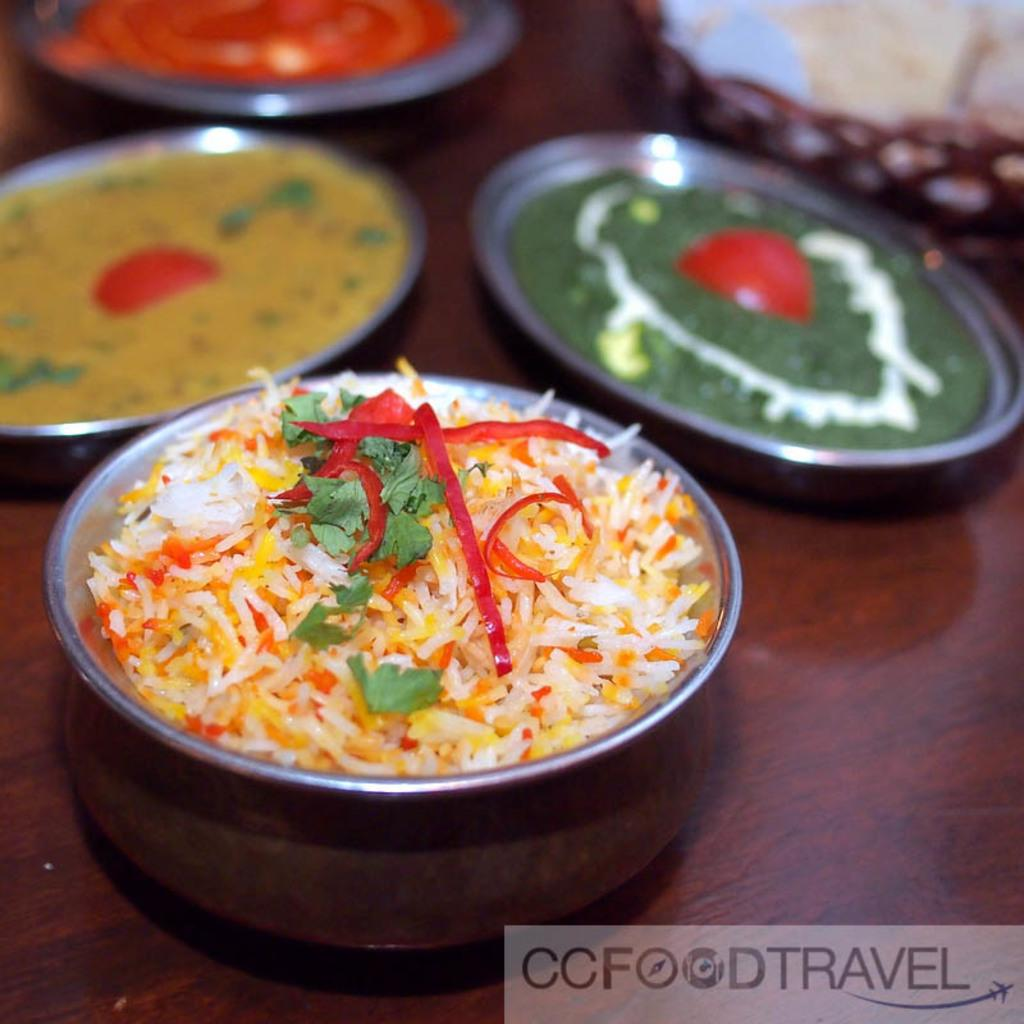What is present in the image that can hold food? There is a bowl and plates in the image that can hold food. What other object can be seen in the image? There is a basket in the image. What type of surface is visible in the image? The wooden surface is visible in the image. Can you describe the food in the image? The image contains food, but the specific type of food is not mentioned. What type of lace can be seen on the plates in the image? There is no lace present on the plates in the image. Is there a bike visible in the image? No, there is no bike present in the image. 